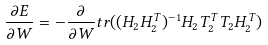<formula> <loc_0><loc_0><loc_500><loc_500>\frac { \partial E } { \partial W } = - \frac { \partial } { \partial W } t r ( ( H _ { 2 } H _ { 2 } ^ { T } ) ^ { - 1 } H _ { 2 } T _ { 2 } ^ { T } T _ { 2 } H _ { 2 } ^ { T } )</formula> 